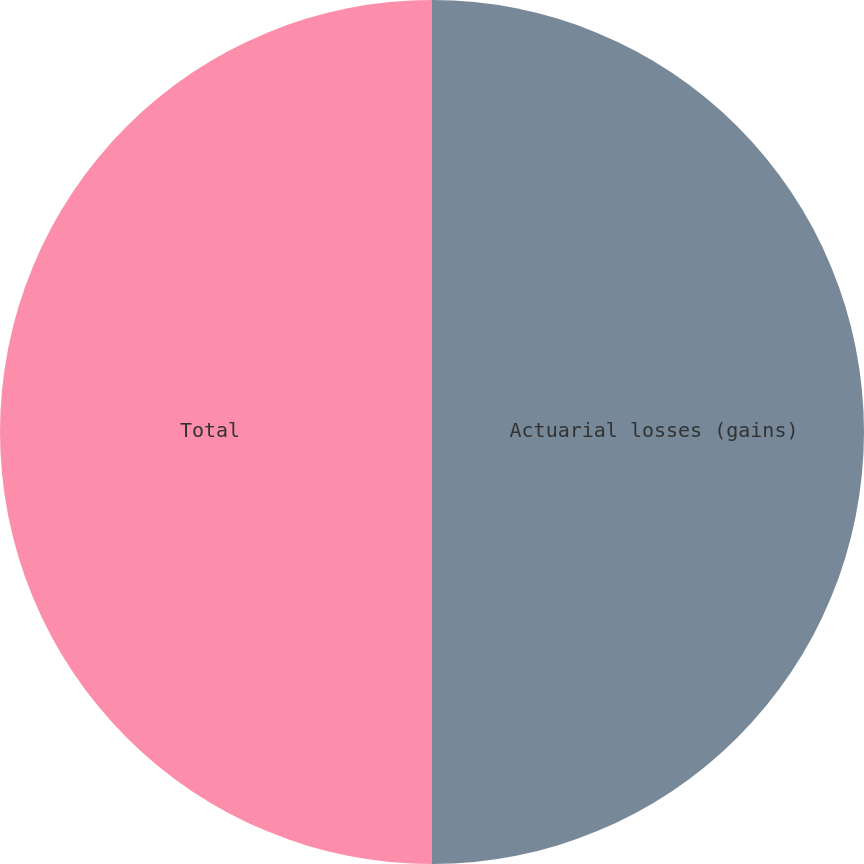Convert chart. <chart><loc_0><loc_0><loc_500><loc_500><pie_chart><fcel>Actuarial losses (gains)<fcel>Total<nl><fcel>50.0%<fcel>50.0%<nl></chart> 